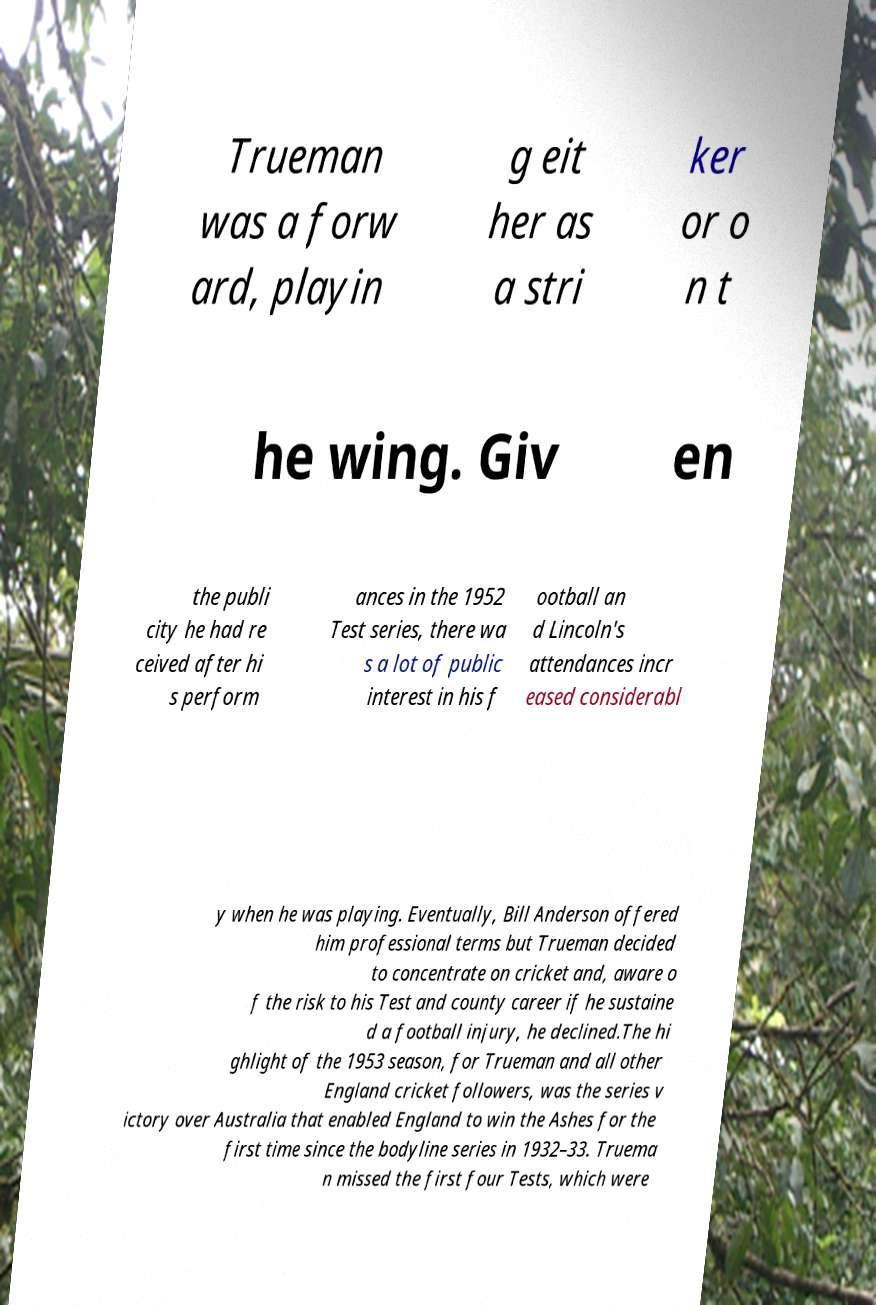What messages or text are displayed in this image? I need them in a readable, typed format. Trueman was a forw ard, playin g eit her as a stri ker or o n t he wing. Giv en the publi city he had re ceived after hi s perform ances in the 1952 Test series, there wa s a lot of public interest in his f ootball an d Lincoln's attendances incr eased considerabl y when he was playing. Eventually, Bill Anderson offered him professional terms but Trueman decided to concentrate on cricket and, aware o f the risk to his Test and county career if he sustaine d a football injury, he declined.The hi ghlight of the 1953 season, for Trueman and all other England cricket followers, was the series v ictory over Australia that enabled England to win the Ashes for the first time since the bodyline series in 1932–33. Truema n missed the first four Tests, which were 